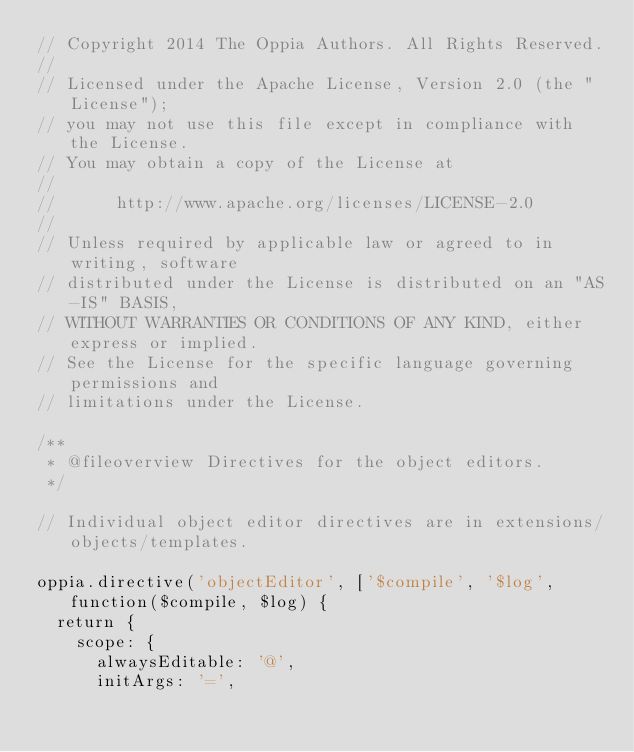Convert code to text. <code><loc_0><loc_0><loc_500><loc_500><_JavaScript_>// Copyright 2014 The Oppia Authors. All Rights Reserved.
//
// Licensed under the Apache License, Version 2.0 (the "License");
// you may not use this file except in compliance with the License.
// You may obtain a copy of the License at
//
//      http://www.apache.org/licenses/LICENSE-2.0
//
// Unless required by applicable law or agreed to in writing, software
// distributed under the License is distributed on an "AS-IS" BASIS,
// WITHOUT WARRANTIES OR CONDITIONS OF ANY KIND, either express or implied.
// See the License for the specific language governing permissions and
// limitations under the License.

/**
 * @fileoverview Directives for the object editors.
 */

// Individual object editor directives are in extensions/objects/templates.

oppia.directive('objectEditor', ['$compile', '$log', function($compile, $log) {
  return {
    scope: {
      alwaysEditable: '@',
      initArgs: '=',</code> 